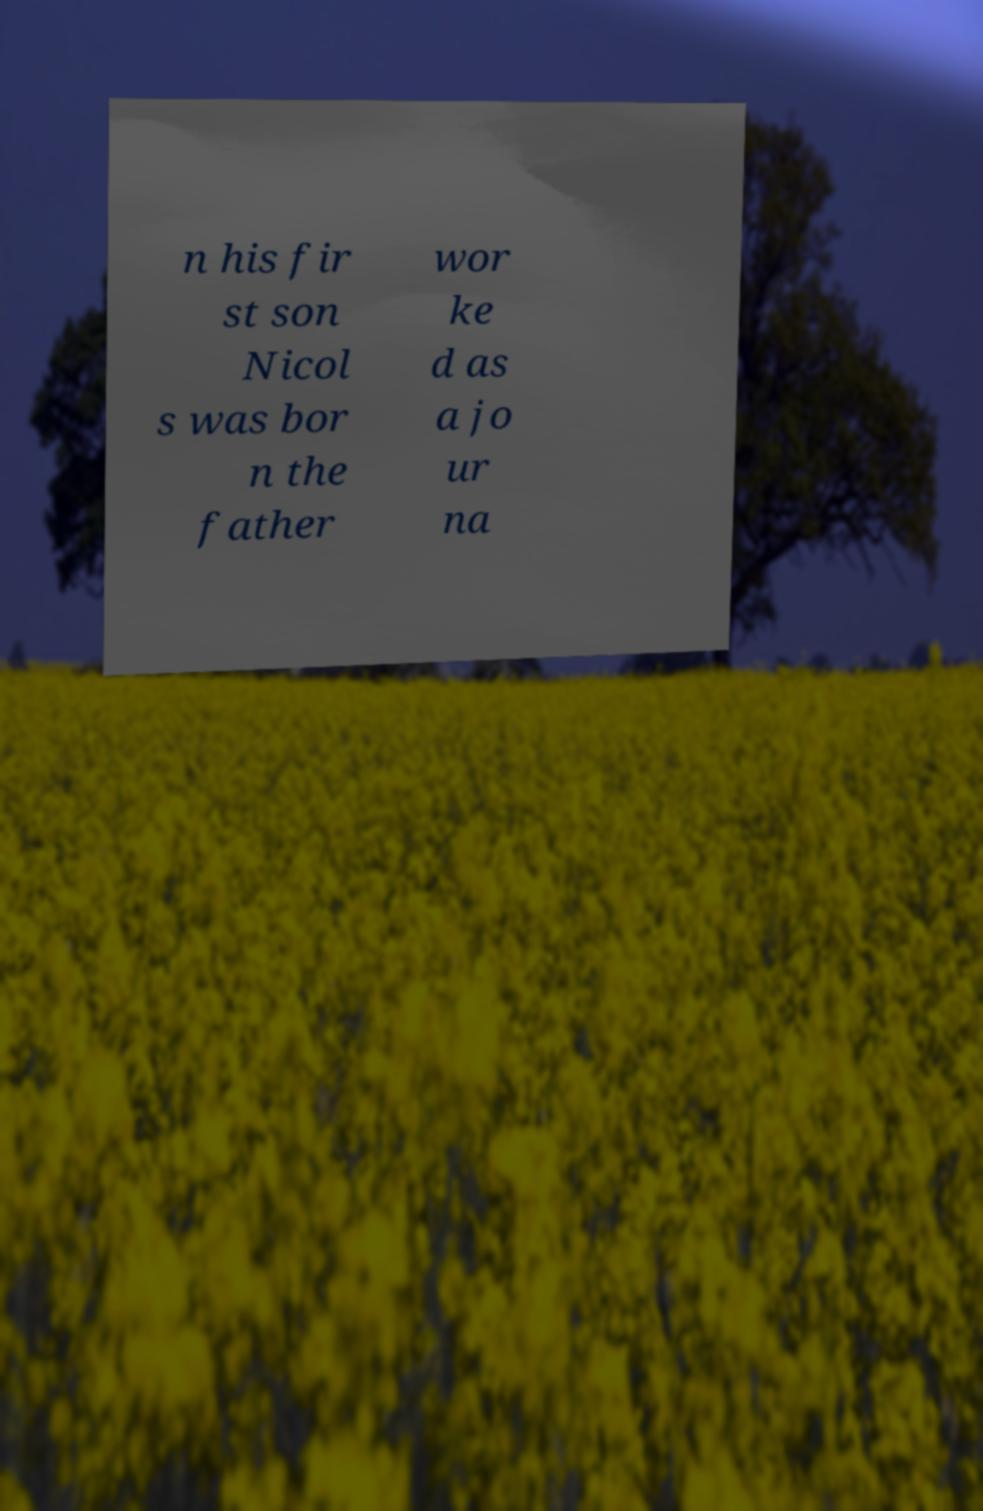For documentation purposes, I need the text within this image transcribed. Could you provide that? n his fir st son Nicol s was bor n the father wor ke d as a jo ur na 